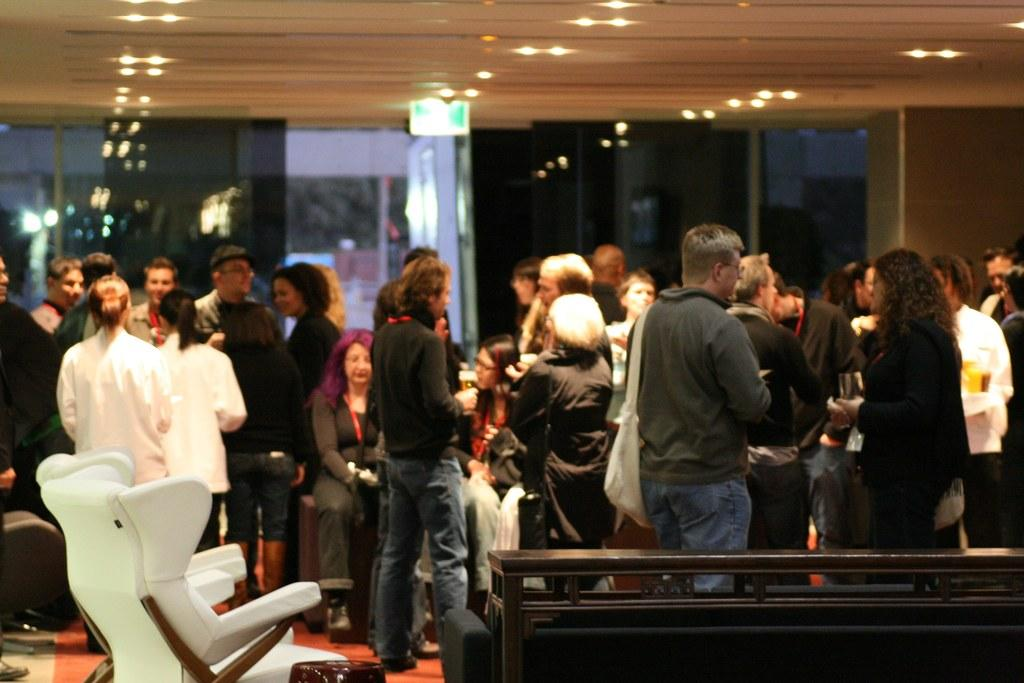What type of vegetation can be seen in the image? There are trees in the image. What object can be used for placing items on in the image? There is a table in the image. What group of people can be seen in the image? A crowd is present in the middle of the image. What architectural feature is visible in the background of the image? There is a glass wall in the background of the image. What type of grass is growing on the table in the image? There is no grass present on the table in the image. How many fingers can be seen holding the glass wall in the image? There are no fingers holding the glass wall in the image. 